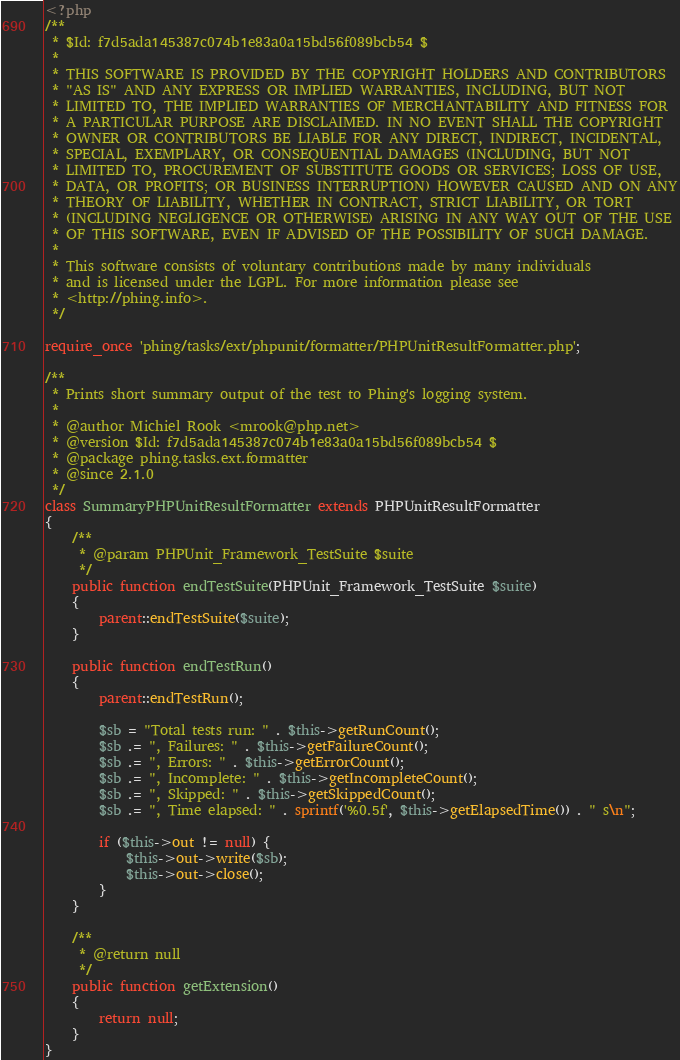<code> <loc_0><loc_0><loc_500><loc_500><_PHP_><?php
/**
 * $Id: f7d5ada145387c074b1e83a0a15bd56f089bcb54 $
 *
 * THIS SOFTWARE IS PROVIDED BY THE COPYRIGHT HOLDERS AND CONTRIBUTORS
 * "AS IS" AND ANY EXPRESS OR IMPLIED WARRANTIES, INCLUDING, BUT NOT
 * LIMITED TO, THE IMPLIED WARRANTIES OF MERCHANTABILITY AND FITNESS FOR
 * A PARTICULAR PURPOSE ARE DISCLAIMED. IN NO EVENT SHALL THE COPYRIGHT
 * OWNER OR CONTRIBUTORS BE LIABLE FOR ANY DIRECT, INDIRECT, INCIDENTAL,
 * SPECIAL, EXEMPLARY, OR CONSEQUENTIAL DAMAGES (INCLUDING, BUT NOT
 * LIMITED TO, PROCUREMENT OF SUBSTITUTE GOODS OR SERVICES; LOSS OF USE,
 * DATA, OR PROFITS; OR BUSINESS INTERRUPTION) HOWEVER CAUSED AND ON ANY
 * THEORY OF LIABILITY, WHETHER IN CONTRACT, STRICT LIABILITY, OR TORT
 * (INCLUDING NEGLIGENCE OR OTHERWISE) ARISING IN ANY WAY OUT OF THE USE
 * OF THIS SOFTWARE, EVEN IF ADVISED OF THE POSSIBILITY OF SUCH DAMAGE.
 *
 * This software consists of voluntary contributions made by many individuals
 * and is licensed under the LGPL. For more information please see
 * <http://phing.info>.
 */

require_once 'phing/tasks/ext/phpunit/formatter/PHPUnitResultFormatter.php';

/**
 * Prints short summary output of the test to Phing's logging system.
 *
 * @author Michiel Rook <mrook@php.net>
 * @version $Id: f7d5ada145387c074b1e83a0a15bd56f089bcb54 $
 * @package phing.tasks.ext.formatter
 * @since 2.1.0
 */
class SummaryPHPUnitResultFormatter extends PHPUnitResultFormatter
{
    /**
     * @param PHPUnit_Framework_TestSuite $suite
     */
    public function endTestSuite(PHPUnit_Framework_TestSuite $suite)
    {
        parent::endTestSuite($suite);
    }

    public function endTestRun()
    {
        parent::endTestRun();

        $sb = "Total tests run: " . $this->getRunCount();
        $sb .= ", Failures: " . $this->getFailureCount();
        $sb .= ", Errors: " . $this->getErrorCount();
        $sb .= ", Incomplete: " . $this->getIncompleteCount();
        $sb .= ", Skipped: " . $this->getSkippedCount();
        $sb .= ", Time elapsed: " . sprintf('%0.5f', $this->getElapsedTime()) . " s\n";

        if ($this->out != null) {
            $this->out->write($sb);
            $this->out->close();
        }
    }

    /**
     * @return null
     */
    public function getExtension()
    {
        return null;
    }
}
</code> 